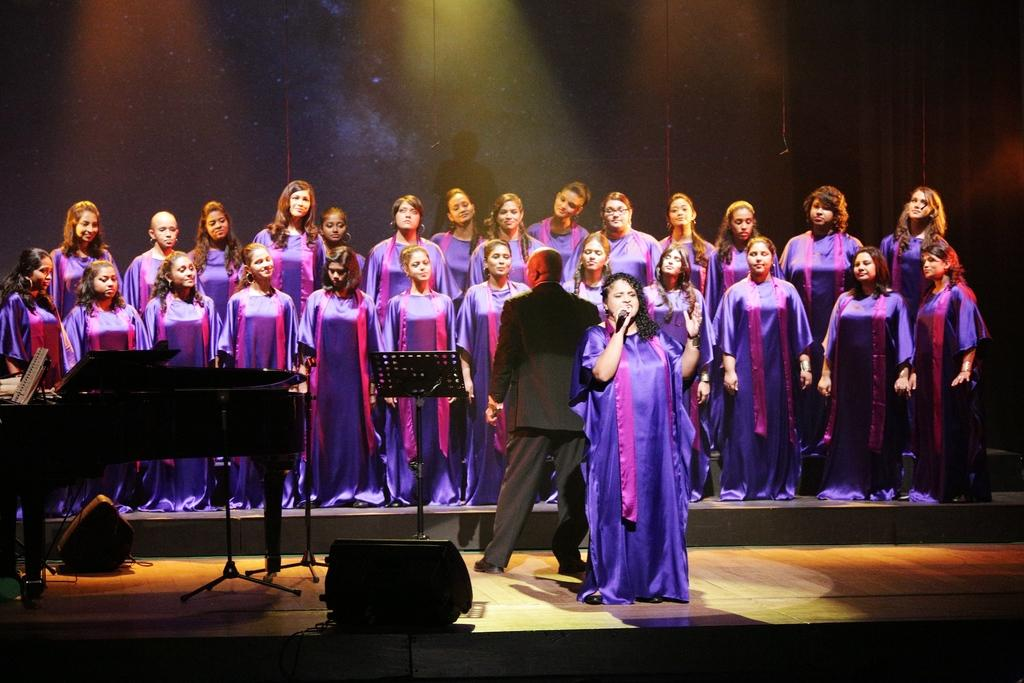What are the people in the image doing? The people in the image are standing. What is the woman holding in the image? The woman is holding a microphone in the image. What musical instrument can be seen on the left side of the image? There is a piano on the left side of the image. What object is present in the image that might be used for holding sheet music or other items? There is a stand in the image. What type of bell can be heard ringing in the image? There is no bell present in the image, and therefore no sound can be heard. 